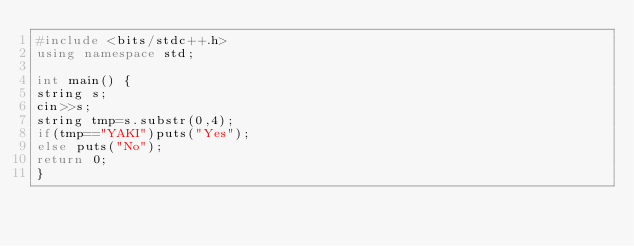Convert code to text. <code><loc_0><loc_0><loc_500><loc_500><_C++_>#include <bits/stdc++.h>
using namespace std;

int main() {
string s;
cin>>s;
string tmp=s.substr(0,4);
if(tmp=="YAKI")puts("Yes");
else puts("No");
return 0;
}</code> 